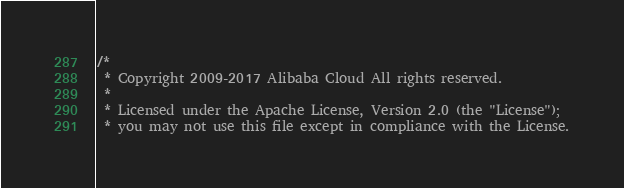Convert code to text. <code><loc_0><loc_0><loc_500><loc_500><_C_>/*
 * Copyright 2009-2017 Alibaba Cloud All rights reserved.
 * 
 * Licensed under the Apache License, Version 2.0 (the "License");
 * you may not use this file except in compliance with the License.</code> 